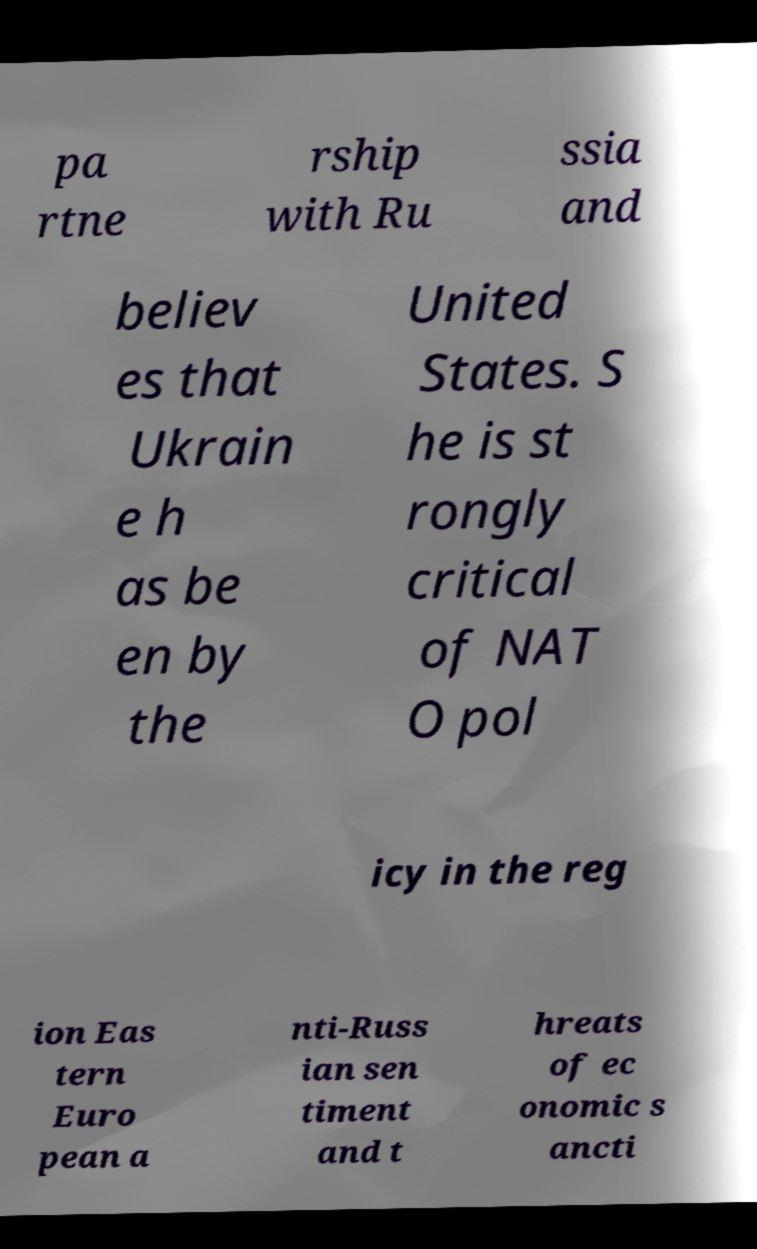Can you read and provide the text displayed in the image?This photo seems to have some interesting text. Can you extract and type it out for me? pa rtne rship with Ru ssia and believ es that Ukrain e h as be en by the United States. S he is st rongly critical of NAT O pol icy in the reg ion Eas tern Euro pean a nti-Russ ian sen timent and t hreats of ec onomic s ancti 